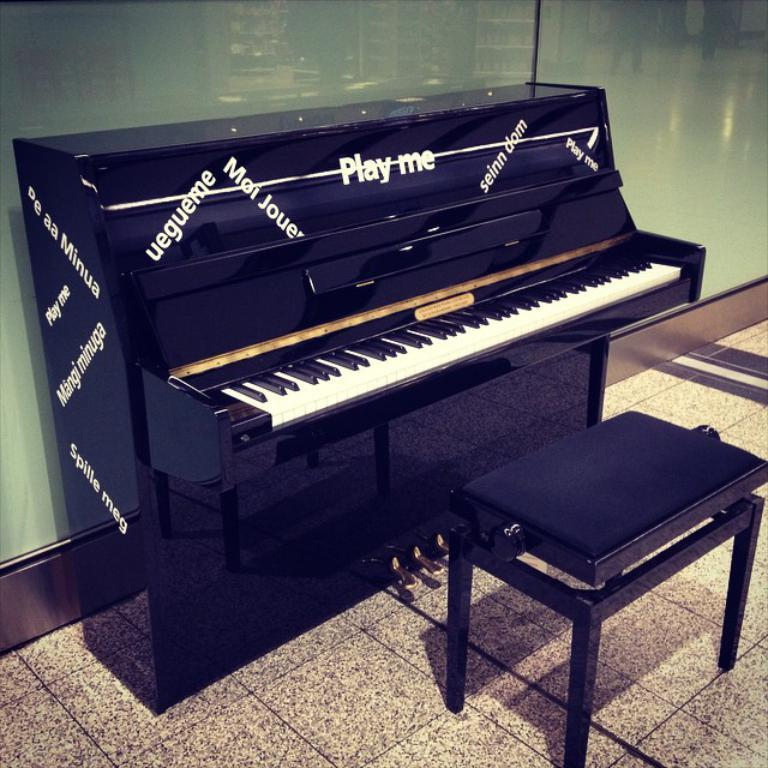What musical instrument is present in the image? There is a piano in the image. What is positioned in front of the piano? There is a chair in front of the piano. Can you describe an object in the background of the image? There is a glass in the background of the image. How many beds can be seen in the image? There are no beds present in the image. What type of bucket is used to collect water in the image? There is no bucket present in the image. 